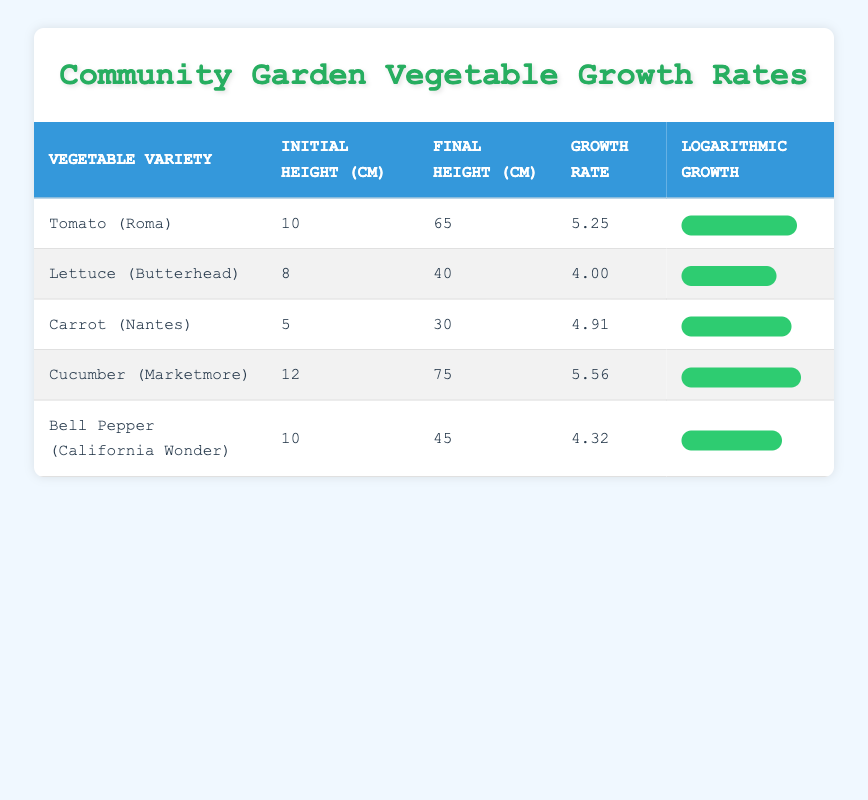What is the initial height of Cucumber (Marketmore)? The table shows the initial height of Cucumber (Marketmore) is listed as 12 cm.
Answer: 12 cm Which vegetable variety has the highest growth rate? By comparing the growth rates listed in the table, Cucumber (Marketmore) has the highest growth rate of 5.56.
Answer: Cucumber (Marketmore) What is the final height of Lettuce (Butterhead)? The final height for Lettuce (Butterhead) in the table is given as 40 cm.
Answer: 40 cm Is the growth rate of Bell Pepper (California Wonder) greater than 5.0? Looking at the growth rate for Bell Pepper (California Wonder), it is 4.32, which is less than 5.0, so the answer is no.
Answer: No What is the average growth rate of all vegetable varieties listed? To find the average growth rate, sum the growth rates (5.25 + 4.00 + 4.91 + 5.56 + 4.32 = 24.04) and then divide by the number of varieties (24.04 / 5 = 4.808).
Answer: 4.81 How much taller is Cucumber (Marketmore) compared to Lettuce (Butterhead) at their final heights? To determine the difference in final heights, subtract the final height of Lettuce (40 cm) from Cucumber (75 cm), resulting in 75 - 40 = 35 cm.
Answer: 35 cm Which vegetable had the smallest initial height? By examining the initial heights of all vegetable varieties, Carrot (Nantes) has the smallest initial height of 5 cm.
Answer: Carrot (Nantes) Are the growth rates of Tomato (Roma) and Carrot (Nantes) greater than the average growth rate of 4.81? Checking the growth rates, Tomato (Roma) is 5.25 and Carrot (Nantes) is 4.91. Both are above the average of 4.81. Therefore, the answer is yes.
Answer: Yes What is the difference between the initial height of the tallest vegetable and the shortest vegetable? The tallest initial height is from Cucumber (Marketmore) at 12 cm and the shortest is from Carrot (Nantes) at 5 cm. The difference is 12 - 5 = 7 cm.
Answer: 7 cm 